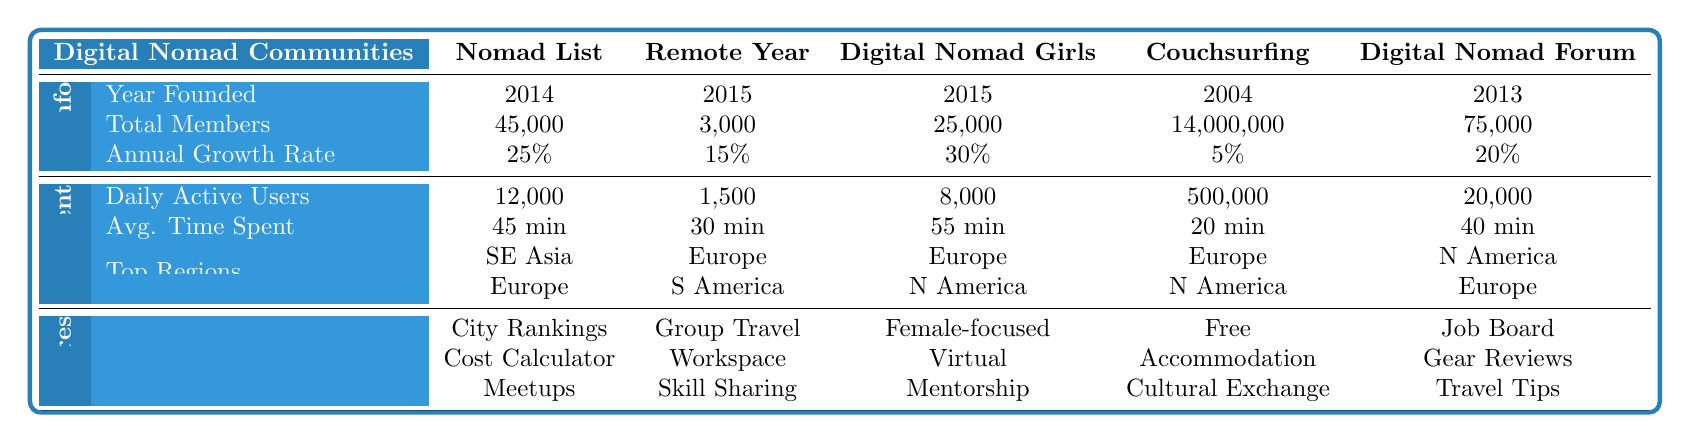What year was Digital Nomad Girls founded? According to the table, the 'Year Founded' for Digital Nomad Girls is listed as 2015.
Answer: 2015 Which community has the highest annual growth rate? From the table, Digital Nomad Girls shows an annual growth rate of 30%, which is the highest among all communities listed.
Answer: Digital Nomad Girls How many total members does Couchsurfing have? The table states that Couchsurfing has a total of 14,000,000 members.
Answer: 14,000,000 What is the average daily active users across the communities listed? To find the average, we add the daily active users of each community: (12000 + 1500 + 8000 + 500000 + 20000) = 537512. Then divide this sum by the number of communities (5): 537512 / 5 = 107502.4.
Answer: 107502.4 Which community has the lowest average time spent by users? By inspecting the table, Couchsurfing has an average time spent of 20 minutes, which is the lowest compared to other communities.
Answer: Couchsurfing True or False: Nomad List has more members than Remote Year. The table indicates that Nomad List has 45,000 members and Remote Year has only 3,000 members, so the statement is true.
Answer: True Which region is listed as the most active for Digital Nomad Forum? Referring to the table, the top active regions for Digital Nomad Forum include North America, Europe, and Asia.
Answer: North America, Europe, Asia If we combine the total members of Nomad List and Digital Nomad Girls, how many members would that be? Adding the total members: 45,000 (Nomad List) + 25,000 (Digital Nomad Girls) = 70,000 members.
Answer: 70,000 Which community has the most popular features related to cultural exchange? Based on the table, Couchsurfing features "Cultural Exchange," indicating it focuses on cultural connections.
Answer: Couchsurfing How does the daily active user count of Couchsurfing compare to Digital Nomad Girls? Couchsurfing has 500,000 daily active users while Digital Nomad Girls has 8,000. Couchsurfing's count is significantly higher.
Answer: Couchsurfing is higher 